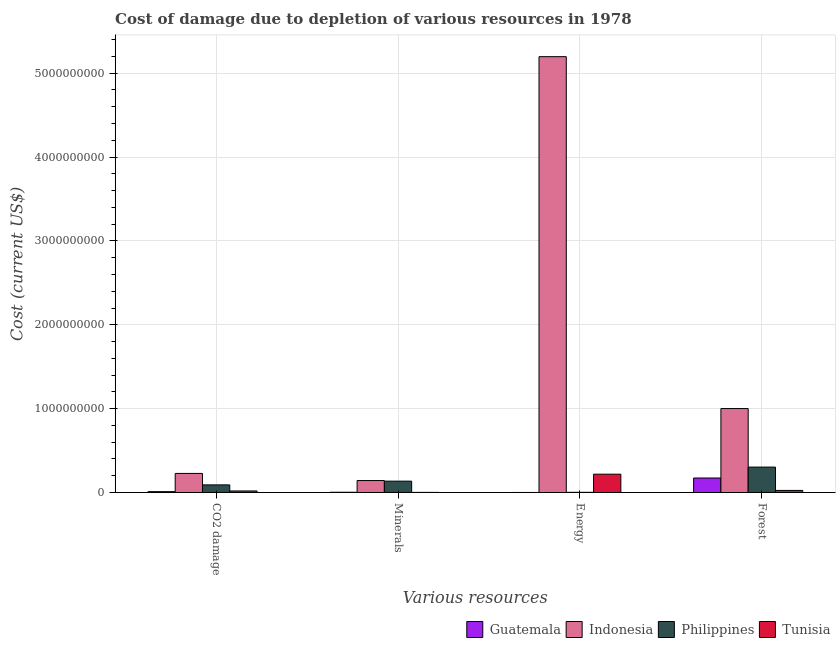How many different coloured bars are there?
Provide a short and direct response. 4. How many groups of bars are there?
Provide a short and direct response. 4. Are the number of bars per tick equal to the number of legend labels?
Ensure brevity in your answer.  Yes. Are the number of bars on each tick of the X-axis equal?
Your answer should be compact. Yes. How many bars are there on the 3rd tick from the left?
Your answer should be very brief. 4. How many bars are there on the 3rd tick from the right?
Provide a short and direct response. 4. What is the label of the 2nd group of bars from the left?
Offer a very short reply. Minerals. What is the cost of damage due to depletion of energy in Tunisia?
Your response must be concise. 2.18e+08. Across all countries, what is the maximum cost of damage due to depletion of energy?
Your answer should be compact. 5.20e+09. Across all countries, what is the minimum cost of damage due to depletion of coal?
Offer a terse response. 9.99e+06. In which country was the cost of damage due to depletion of coal minimum?
Your answer should be very brief. Guatemala. What is the total cost of damage due to depletion of coal in the graph?
Make the answer very short. 3.46e+08. What is the difference between the cost of damage due to depletion of forests in Tunisia and that in Guatemala?
Your response must be concise. -1.48e+08. What is the difference between the cost of damage due to depletion of coal in Philippines and the cost of damage due to depletion of energy in Tunisia?
Make the answer very short. -1.28e+08. What is the average cost of damage due to depletion of forests per country?
Offer a terse response. 3.75e+08. What is the difference between the cost of damage due to depletion of coal and cost of damage due to depletion of minerals in Guatemala?
Provide a succinct answer. 7.25e+06. What is the ratio of the cost of damage due to depletion of forests in Philippines to that in Tunisia?
Offer a terse response. 12.27. What is the difference between the highest and the second highest cost of damage due to depletion of minerals?
Give a very brief answer. 7.25e+06. What is the difference between the highest and the lowest cost of damage due to depletion of energy?
Make the answer very short. 5.20e+09. In how many countries, is the cost of damage due to depletion of coal greater than the average cost of damage due to depletion of coal taken over all countries?
Ensure brevity in your answer.  2. Is it the case that in every country, the sum of the cost of damage due to depletion of energy and cost of damage due to depletion of forests is greater than the sum of cost of damage due to depletion of minerals and cost of damage due to depletion of coal?
Your response must be concise. No. What does the 4th bar from the left in CO2 damage represents?
Your answer should be compact. Tunisia. How many countries are there in the graph?
Give a very brief answer. 4. Are the values on the major ticks of Y-axis written in scientific E-notation?
Your answer should be compact. No. Does the graph contain any zero values?
Offer a terse response. No. How are the legend labels stacked?
Provide a short and direct response. Horizontal. What is the title of the graph?
Your answer should be very brief. Cost of damage due to depletion of various resources in 1978 . Does "Jamaica" appear as one of the legend labels in the graph?
Your answer should be very brief. No. What is the label or title of the X-axis?
Your answer should be compact. Various resources. What is the label or title of the Y-axis?
Give a very brief answer. Cost (current US$). What is the Cost (current US$) in Guatemala in CO2 damage?
Provide a short and direct response. 9.99e+06. What is the Cost (current US$) of Indonesia in CO2 damage?
Offer a very short reply. 2.27e+08. What is the Cost (current US$) in Philippines in CO2 damage?
Your response must be concise. 9.06e+07. What is the Cost (current US$) in Tunisia in CO2 damage?
Your response must be concise. 1.81e+07. What is the Cost (current US$) in Guatemala in Minerals?
Your answer should be very brief. 2.74e+06. What is the Cost (current US$) of Indonesia in Minerals?
Your answer should be compact. 1.43e+08. What is the Cost (current US$) in Philippines in Minerals?
Your answer should be compact. 1.35e+08. What is the Cost (current US$) of Tunisia in Minerals?
Ensure brevity in your answer.  1.03e+06. What is the Cost (current US$) of Guatemala in Energy?
Your answer should be very brief. 1.10e+05. What is the Cost (current US$) of Indonesia in Energy?
Make the answer very short. 5.20e+09. What is the Cost (current US$) in Philippines in Energy?
Keep it short and to the point. 2.02e+06. What is the Cost (current US$) of Tunisia in Energy?
Your answer should be very brief. 2.18e+08. What is the Cost (current US$) in Guatemala in Forest?
Offer a very short reply. 1.73e+08. What is the Cost (current US$) of Indonesia in Forest?
Give a very brief answer. 1.00e+09. What is the Cost (current US$) in Philippines in Forest?
Your response must be concise. 3.03e+08. What is the Cost (current US$) of Tunisia in Forest?
Offer a terse response. 2.47e+07. Across all Various resources, what is the maximum Cost (current US$) in Guatemala?
Give a very brief answer. 1.73e+08. Across all Various resources, what is the maximum Cost (current US$) of Indonesia?
Give a very brief answer. 5.20e+09. Across all Various resources, what is the maximum Cost (current US$) in Philippines?
Provide a short and direct response. 3.03e+08. Across all Various resources, what is the maximum Cost (current US$) of Tunisia?
Ensure brevity in your answer.  2.18e+08. Across all Various resources, what is the minimum Cost (current US$) of Guatemala?
Ensure brevity in your answer.  1.10e+05. Across all Various resources, what is the minimum Cost (current US$) of Indonesia?
Offer a very short reply. 1.43e+08. Across all Various resources, what is the minimum Cost (current US$) in Philippines?
Make the answer very short. 2.02e+06. Across all Various resources, what is the minimum Cost (current US$) in Tunisia?
Your answer should be very brief. 1.03e+06. What is the total Cost (current US$) in Guatemala in the graph?
Make the answer very short. 1.86e+08. What is the total Cost (current US$) in Indonesia in the graph?
Offer a very short reply. 6.57e+09. What is the total Cost (current US$) in Philippines in the graph?
Provide a short and direct response. 5.31e+08. What is the total Cost (current US$) of Tunisia in the graph?
Offer a very short reply. 2.62e+08. What is the difference between the Cost (current US$) in Guatemala in CO2 damage and that in Minerals?
Make the answer very short. 7.25e+06. What is the difference between the Cost (current US$) in Indonesia in CO2 damage and that in Minerals?
Provide a short and direct response. 8.47e+07. What is the difference between the Cost (current US$) in Philippines in CO2 damage and that in Minerals?
Your response must be concise. -4.46e+07. What is the difference between the Cost (current US$) in Tunisia in CO2 damage and that in Minerals?
Make the answer very short. 1.71e+07. What is the difference between the Cost (current US$) in Guatemala in CO2 damage and that in Energy?
Offer a terse response. 9.88e+06. What is the difference between the Cost (current US$) in Indonesia in CO2 damage and that in Energy?
Ensure brevity in your answer.  -4.97e+09. What is the difference between the Cost (current US$) in Philippines in CO2 damage and that in Energy?
Your answer should be very brief. 8.86e+07. What is the difference between the Cost (current US$) of Tunisia in CO2 damage and that in Energy?
Provide a short and direct response. -2.00e+08. What is the difference between the Cost (current US$) in Guatemala in CO2 damage and that in Forest?
Keep it short and to the point. -1.63e+08. What is the difference between the Cost (current US$) of Indonesia in CO2 damage and that in Forest?
Ensure brevity in your answer.  -7.74e+08. What is the difference between the Cost (current US$) in Philippines in CO2 damage and that in Forest?
Keep it short and to the point. -2.12e+08. What is the difference between the Cost (current US$) of Tunisia in CO2 damage and that in Forest?
Provide a succinct answer. -6.58e+06. What is the difference between the Cost (current US$) of Guatemala in Minerals and that in Energy?
Keep it short and to the point. 2.63e+06. What is the difference between the Cost (current US$) in Indonesia in Minerals and that in Energy?
Your response must be concise. -5.05e+09. What is the difference between the Cost (current US$) of Philippines in Minerals and that in Energy?
Give a very brief answer. 1.33e+08. What is the difference between the Cost (current US$) of Tunisia in Minerals and that in Energy?
Ensure brevity in your answer.  -2.17e+08. What is the difference between the Cost (current US$) in Guatemala in Minerals and that in Forest?
Make the answer very short. -1.70e+08. What is the difference between the Cost (current US$) of Indonesia in Minerals and that in Forest?
Provide a short and direct response. -8.58e+08. What is the difference between the Cost (current US$) of Philippines in Minerals and that in Forest?
Offer a very short reply. -1.68e+08. What is the difference between the Cost (current US$) of Tunisia in Minerals and that in Forest?
Make the answer very short. -2.37e+07. What is the difference between the Cost (current US$) of Guatemala in Energy and that in Forest?
Your answer should be compact. -1.73e+08. What is the difference between the Cost (current US$) in Indonesia in Energy and that in Forest?
Your answer should be very brief. 4.20e+09. What is the difference between the Cost (current US$) of Philippines in Energy and that in Forest?
Offer a terse response. -3.01e+08. What is the difference between the Cost (current US$) of Tunisia in Energy and that in Forest?
Keep it short and to the point. 1.94e+08. What is the difference between the Cost (current US$) in Guatemala in CO2 damage and the Cost (current US$) in Indonesia in Minerals?
Ensure brevity in your answer.  -1.33e+08. What is the difference between the Cost (current US$) of Guatemala in CO2 damage and the Cost (current US$) of Philippines in Minerals?
Provide a short and direct response. -1.25e+08. What is the difference between the Cost (current US$) in Guatemala in CO2 damage and the Cost (current US$) in Tunisia in Minerals?
Give a very brief answer. 8.95e+06. What is the difference between the Cost (current US$) of Indonesia in CO2 damage and the Cost (current US$) of Philippines in Minerals?
Provide a short and direct response. 9.19e+07. What is the difference between the Cost (current US$) of Indonesia in CO2 damage and the Cost (current US$) of Tunisia in Minerals?
Keep it short and to the point. 2.26e+08. What is the difference between the Cost (current US$) in Philippines in CO2 damage and the Cost (current US$) in Tunisia in Minerals?
Ensure brevity in your answer.  8.96e+07. What is the difference between the Cost (current US$) of Guatemala in CO2 damage and the Cost (current US$) of Indonesia in Energy?
Your response must be concise. -5.19e+09. What is the difference between the Cost (current US$) in Guatemala in CO2 damage and the Cost (current US$) in Philippines in Energy?
Keep it short and to the point. 7.97e+06. What is the difference between the Cost (current US$) of Guatemala in CO2 damage and the Cost (current US$) of Tunisia in Energy?
Ensure brevity in your answer.  -2.08e+08. What is the difference between the Cost (current US$) in Indonesia in CO2 damage and the Cost (current US$) in Philippines in Energy?
Offer a terse response. 2.25e+08. What is the difference between the Cost (current US$) in Indonesia in CO2 damage and the Cost (current US$) in Tunisia in Energy?
Provide a short and direct response. 8.91e+06. What is the difference between the Cost (current US$) in Philippines in CO2 damage and the Cost (current US$) in Tunisia in Energy?
Ensure brevity in your answer.  -1.28e+08. What is the difference between the Cost (current US$) in Guatemala in CO2 damage and the Cost (current US$) in Indonesia in Forest?
Provide a short and direct response. -9.91e+08. What is the difference between the Cost (current US$) in Guatemala in CO2 damage and the Cost (current US$) in Philippines in Forest?
Your answer should be very brief. -2.93e+08. What is the difference between the Cost (current US$) of Guatemala in CO2 damage and the Cost (current US$) of Tunisia in Forest?
Offer a very short reply. -1.47e+07. What is the difference between the Cost (current US$) in Indonesia in CO2 damage and the Cost (current US$) in Philippines in Forest?
Your answer should be compact. -7.58e+07. What is the difference between the Cost (current US$) in Indonesia in CO2 damage and the Cost (current US$) in Tunisia in Forest?
Offer a terse response. 2.02e+08. What is the difference between the Cost (current US$) of Philippines in CO2 damage and the Cost (current US$) of Tunisia in Forest?
Provide a short and direct response. 6.59e+07. What is the difference between the Cost (current US$) of Guatemala in Minerals and the Cost (current US$) of Indonesia in Energy?
Keep it short and to the point. -5.19e+09. What is the difference between the Cost (current US$) in Guatemala in Minerals and the Cost (current US$) in Philippines in Energy?
Your response must be concise. 7.24e+05. What is the difference between the Cost (current US$) in Guatemala in Minerals and the Cost (current US$) in Tunisia in Energy?
Offer a terse response. -2.16e+08. What is the difference between the Cost (current US$) in Indonesia in Minerals and the Cost (current US$) in Philippines in Energy?
Offer a terse response. 1.41e+08. What is the difference between the Cost (current US$) of Indonesia in Minerals and the Cost (current US$) of Tunisia in Energy?
Your response must be concise. -7.58e+07. What is the difference between the Cost (current US$) in Philippines in Minerals and the Cost (current US$) in Tunisia in Energy?
Offer a terse response. -8.30e+07. What is the difference between the Cost (current US$) in Guatemala in Minerals and the Cost (current US$) in Indonesia in Forest?
Ensure brevity in your answer.  -9.98e+08. What is the difference between the Cost (current US$) of Guatemala in Minerals and the Cost (current US$) of Philippines in Forest?
Give a very brief answer. -3.00e+08. What is the difference between the Cost (current US$) of Guatemala in Minerals and the Cost (current US$) of Tunisia in Forest?
Keep it short and to the point. -2.20e+07. What is the difference between the Cost (current US$) of Indonesia in Minerals and the Cost (current US$) of Philippines in Forest?
Your response must be concise. -1.60e+08. What is the difference between the Cost (current US$) of Indonesia in Minerals and the Cost (current US$) of Tunisia in Forest?
Your answer should be very brief. 1.18e+08. What is the difference between the Cost (current US$) of Philippines in Minerals and the Cost (current US$) of Tunisia in Forest?
Offer a terse response. 1.11e+08. What is the difference between the Cost (current US$) of Guatemala in Energy and the Cost (current US$) of Indonesia in Forest?
Keep it short and to the point. -1.00e+09. What is the difference between the Cost (current US$) in Guatemala in Energy and the Cost (current US$) in Philippines in Forest?
Provide a succinct answer. -3.03e+08. What is the difference between the Cost (current US$) of Guatemala in Energy and the Cost (current US$) of Tunisia in Forest?
Provide a short and direct response. -2.46e+07. What is the difference between the Cost (current US$) of Indonesia in Energy and the Cost (current US$) of Philippines in Forest?
Provide a succinct answer. 4.89e+09. What is the difference between the Cost (current US$) of Indonesia in Energy and the Cost (current US$) of Tunisia in Forest?
Make the answer very short. 5.17e+09. What is the difference between the Cost (current US$) in Philippines in Energy and the Cost (current US$) in Tunisia in Forest?
Offer a terse response. -2.27e+07. What is the average Cost (current US$) in Guatemala per Various resources?
Your answer should be compact. 4.64e+07. What is the average Cost (current US$) in Indonesia per Various resources?
Your answer should be compact. 1.64e+09. What is the average Cost (current US$) of Philippines per Various resources?
Your answer should be compact. 1.33e+08. What is the average Cost (current US$) of Tunisia per Various resources?
Provide a short and direct response. 6.55e+07. What is the difference between the Cost (current US$) in Guatemala and Cost (current US$) in Indonesia in CO2 damage?
Provide a short and direct response. -2.17e+08. What is the difference between the Cost (current US$) in Guatemala and Cost (current US$) in Philippines in CO2 damage?
Ensure brevity in your answer.  -8.07e+07. What is the difference between the Cost (current US$) of Guatemala and Cost (current US$) of Tunisia in CO2 damage?
Provide a succinct answer. -8.13e+06. What is the difference between the Cost (current US$) of Indonesia and Cost (current US$) of Philippines in CO2 damage?
Offer a very short reply. 1.37e+08. What is the difference between the Cost (current US$) of Indonesia and Cost (current US$) of Tunisia in CO2 damage?
Provide a short and direct response. 2.09e+08. What is the difference between the Cost (current US$) in Philippines and Cost (current US$) in Tunisia in CO2 damage?
Provide a short and direct response. 7.25e+07. What is the difference between the Cost (current US$) in Guatemala and Cost (current US$) in Indonesia in Minerals?
Keep it short and to the point. -1.40e+08. What is the difference between the Cost (current US$) of Guatemala and Cost (current US$) of Philippines in Minerals?
Give a very brief answer. -1.33e+08. What is the difference between the Cost (current US$) in Guatemala and Cost (current US$) in Tunisia in Minerals?
Offer a terse response. 1.71e+06. What is the difference between the Cost (current US$) in Indonesia and Cost (current US$) in Philippines in Minerals?
Your answer should be very brief. 7.25e+06. What is the difference between the Cost (current US$) in Indonesia and Cost (current US$) in Tunisia in Minerals?
Your response must be concise. 1.41e+08. What is the difference between the Cost (current US$) of Philippines and Cost (current US$) of Tunisia in Minerals?
Offer a very short reply. 1.34e+08. What is the difference between the Cost (current US$) of Guatemala and Cost (current US$) of Indonesia in Energy?
Make the answer very short. -5.20e+09. What is the difference between the Cost (current US$) of Guatemala and Cost (current US$) of Philippines in Energy?
Make the answer very short. -1.91e+06. What is the difference between the Cost (current US$) in Guatemala and Cost (current US$) in Tunisia in Energy?
Keep it short and to the point. -2.18e+08. What is the difference between the Cost (current US$) in Indonesia and Cost (current US$) in Philippines in Energy?
Your response must be concise. 5.20e+09. What is the difference between the Cost (current US$) of Indonesia and Cost (current US$) of Tunisia in Energy?
Offer a terse response. 4.98e+09. What is the difference between the Cost (current US$) in Philippines and Cost (current US$) in Tunisia in Energy?
Provide a short and direct response. -2.16e+08. What is the difference between the Cost (current US$) of Guatemala and Cost (current US$) of Indonesia in Forest?
Your answer should be compact. -8.28e+08. What is the difference between the Cost (current US$) of Guatemala and Cost (current US$) of Philippines in Forest?
Make the answer very short. -1.30e+08. What is the difference between the Cost (current US$) of Guatemala and Cost (current US$) of Tunisia in Forest?
Keep it short and to the point. 1.48e+08. What is the difference between the Cost (current US$) in Indonesia and Cost (current US$) in Philippines in Forest?
Give a very brief answer. 6.98e+08. What is the difference between the Cost (current US$) in Indonesia and Cost (current US$) in Tunisia in Forest?
Make the answer very short. 9.76e+08. What is the difference between the Cost (current US$) in Philippines and Cost (current US$) in Tunisia in Forest?
Your response must be concise. 2.78e+08. What is the ratio of the Cost (current US$) in Guatemala in CO2 damage to that in Minerals?
Make the answer very short. 3.64. What is the ratio of the Cost (current US$) in Indonesia in CO2 damage to that in Minerals?
Offer a terse response. 1.59. What is the ratio of the Cost (current US$) of Philippines in CO2 damage to that in Minerals?
Your answer should be compact. 0.67. What is the ratio of the Cost (current US$) of Tunisia in CO2 damage to that in Minerals?
Your answer should be very brief. 17.56. What is the ratio of the Cost (current US$) of Guatemala in CO2 damage to that in Energy?
Ensure brevity in your answer.  90.96. What is the ratio of the Cost (current US$) in Indonesia in CO2 damage to that in Energy?
Ensure brevity in your answer.  0.04. What is the ratio of the Cost (current US$) of Philippines in CO2 damage to that in Energy?
Make the answer very short. 44.93. What is the ratio of the Cost (current US$) of Tunisia in CO2 damage to that in Energy?
Offer a terse response. 0.08. What is the ratio of the Cost (current US$) of Guatemala in CO2 damage to that in Forest?
Offer a terse response. 0.06. What is the ratio of the Cost (current US$) in Indonesia in CO2 damage to that in Forest?
Give a very brief answer. 0.23. What is the ratio of the Cost (current US$) of Philippines in CO2 damage to that in Forest?
Make the answer very short. 0.3. What is the ratio of the Cost (current US$) of Tunisia in CO2 damage to that in Forest?
Give a very brief answer. 0.73. What is the ratio of the Cost (current US$) in Guatemala in Minerals to that in Energy?
Your answer should be very brief. 24.97. What is the ratio of the Cost (current US$) of Indonesia in Minerals to that in Energy?
Keep it short and to the point. 0.03. What is the ratio of the Cost (current US$) in Philippines in Minerals to that in Energy?
Ensure brevity in your answer.  67.06. What is the ratio of the Cost (current US$) in Tunisia in Minerals to that in Energy?
Give a very brief answer. 0. What is the ratio of the Cost (current US$) of Guatemala in Minerals to that in Forest?
Offer a terse response. 0.02. What is the ratio of the Cost (current US$) in Indonesia in Minerals to that in Forest?
Give a very brief answer. 0.14. What is the ratio of the Cost (current US$) of Philippines in Minerals to that in Forest?
Your answer should be very brief. 0.45. What is the ratio of the Cost (current US$) of Tunisia in Minerals to that in Forest?
Provide a short and direct response. 0.04. What is the ratio of the Cost (current US$) in Guatemala in Energy to that in Forest?
Your answer should be very brief. 0. What is the ratio of the Cost (current US$) in Indonesia in Energy to that in Forest?
Offer a terse response. 5.19. What is the ratio of the Cost (current US$) in Philippines in Energy to that in Forest?
Provide a succinct answer. 0.01. What is the ratio of the Cost (current US$) of Tunisia in Energy to that in Forest?
Give a very brief answer. 8.84. What is the difference between the highest and the second highest Cost (current US$) in Guatemala?
Keep it short and to the point. 1.63e+08. What is the difference between the highest and the second highest Cost (current US$) in Indonesia?
Your response must be concise. 4.20e+09. What is the difference between the highest and the second highest Cost (current US$) in Philippines?
Offer a very short reply. 1.68e+08. What is the difference between the highest and the second highest Cost (current US$) of Tunisia?
Your answer should be compact. 1.94e+08. What is the difference between the highest and the lowest Cost (current US$) in Guatemala?
Make the answer very short. 1.73e+08. What is the difference between the highest and the lowest Cost (current US$) in Indonesia?
Your response must be concise. 5.05e+09. What is the difference between the highest and the lowest Cost (current US$) of Philippines?
Give a very brief answer. 3.01e+08. What is the difference between the highest and the lowest Cost (current US$) in Tunisia?
Make the answer very short. 2.17e+08. 